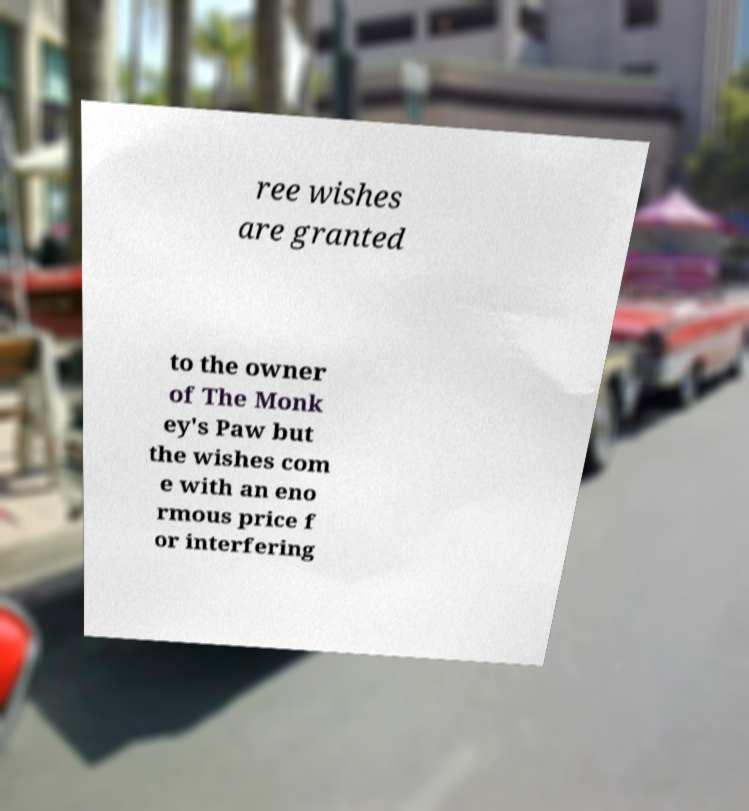For documentation purposes, I need the text within this image transcribed. Could you provide that? ree wishes are granted to the owner of The Monk ey's Paw but the wishes com e with an eno rmous price f or interfering 